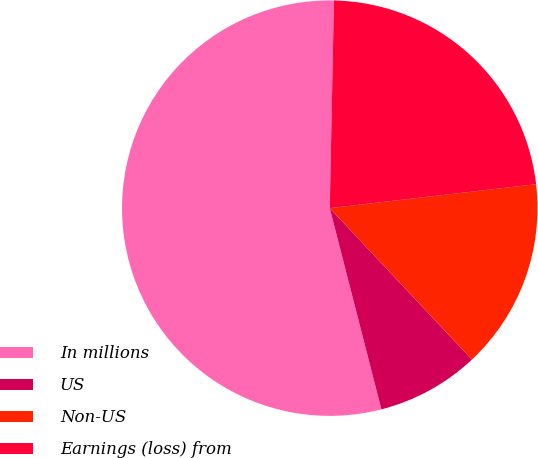Convert chart to OTSL. <chart><loc_0><loc_0><loc_500><loc_500><pie_chart><fcel>In millions<fcel>US<fcel>Non-US<fcel>Earnings (loss) from<nl><fcel>54.32%<fcel>8.0%<fcel>14.84%<fcel>22.84%<nl></chart> 